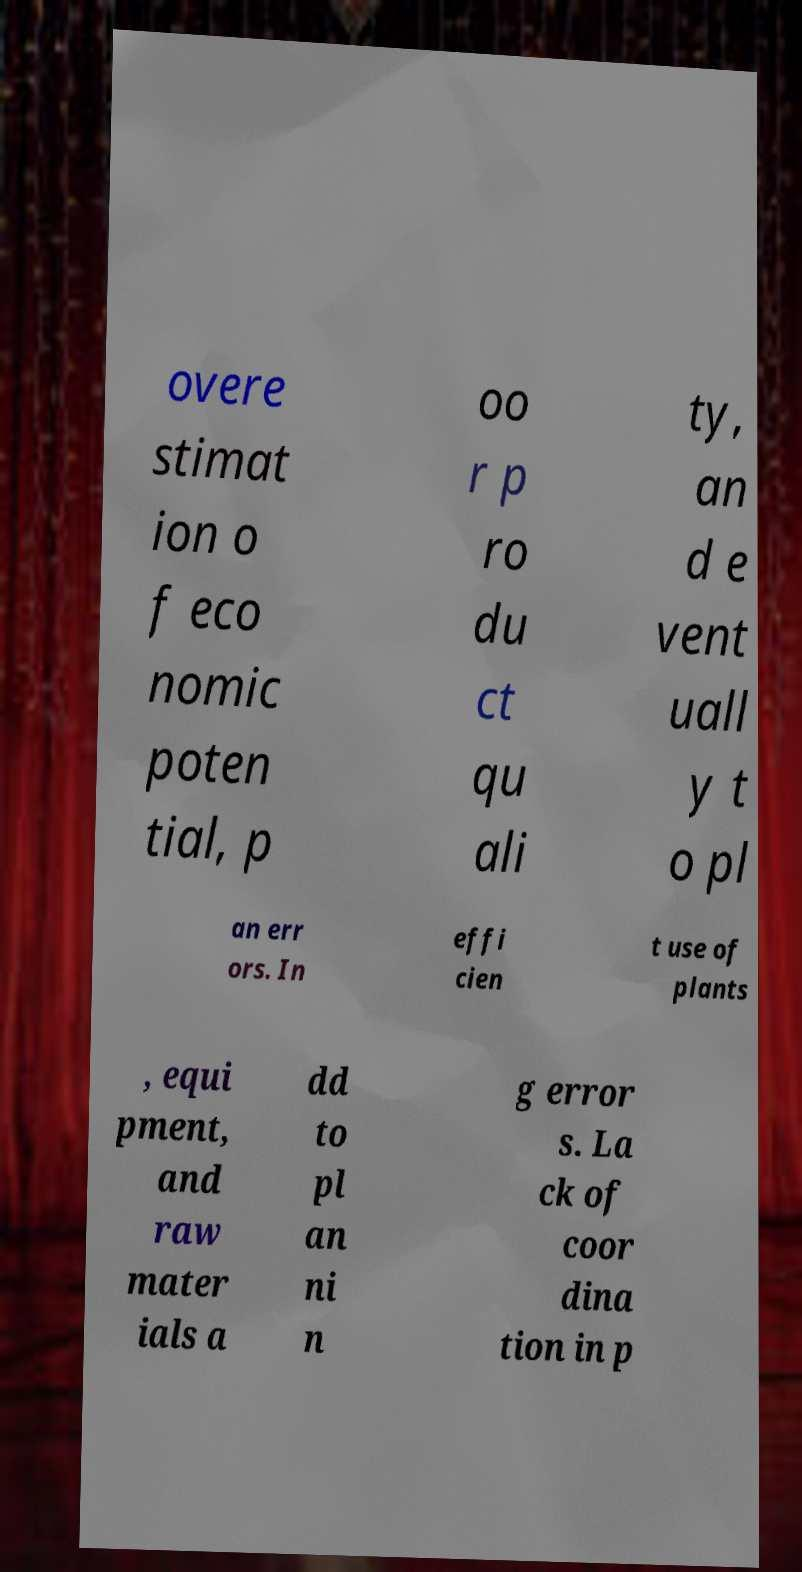Can you accurately transcribe the text from the provided image for me? overe stimat ion o f eco nomic poten tial, p oo r p ro du ct qu ali ty, an d e vent uall y t o pl an err ors. In effi cien t use of plants , equi pment, and raw mater ials a dd to pl an ni n g error s. La ck of coor dina tion in p 